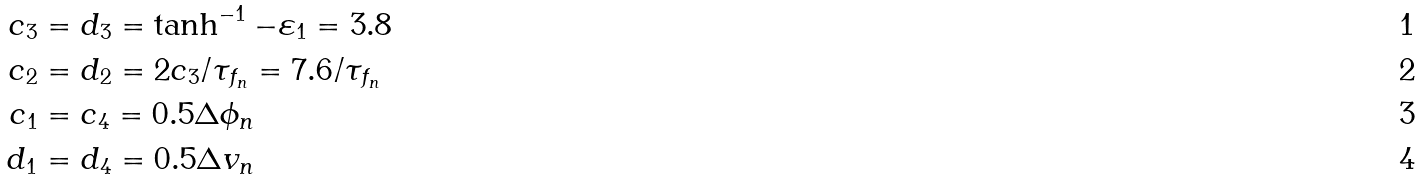Convert formula to latex. <formula><loc_0><loc_0><loc_500><loc_500>c _ { 3 } & = d _ { 3 } = \tanh ^ { - 1 } - \varepsilon _ { 1 } = 3 . 8 \\ c _ { 2 } & = d _ { 2 } = 2 c _ { 3 } / \tau _ { f _ { n } } = 7 . 6 / \tau _ { f _ { n } } \\ c _ { 1 } & = c _ { 4 } = 0 . 5 \Delta \phi _ { n } \\ d _ { 1 } & = d _ { 4 } = 0 . 5 \Delta v _ { n }</formula> 